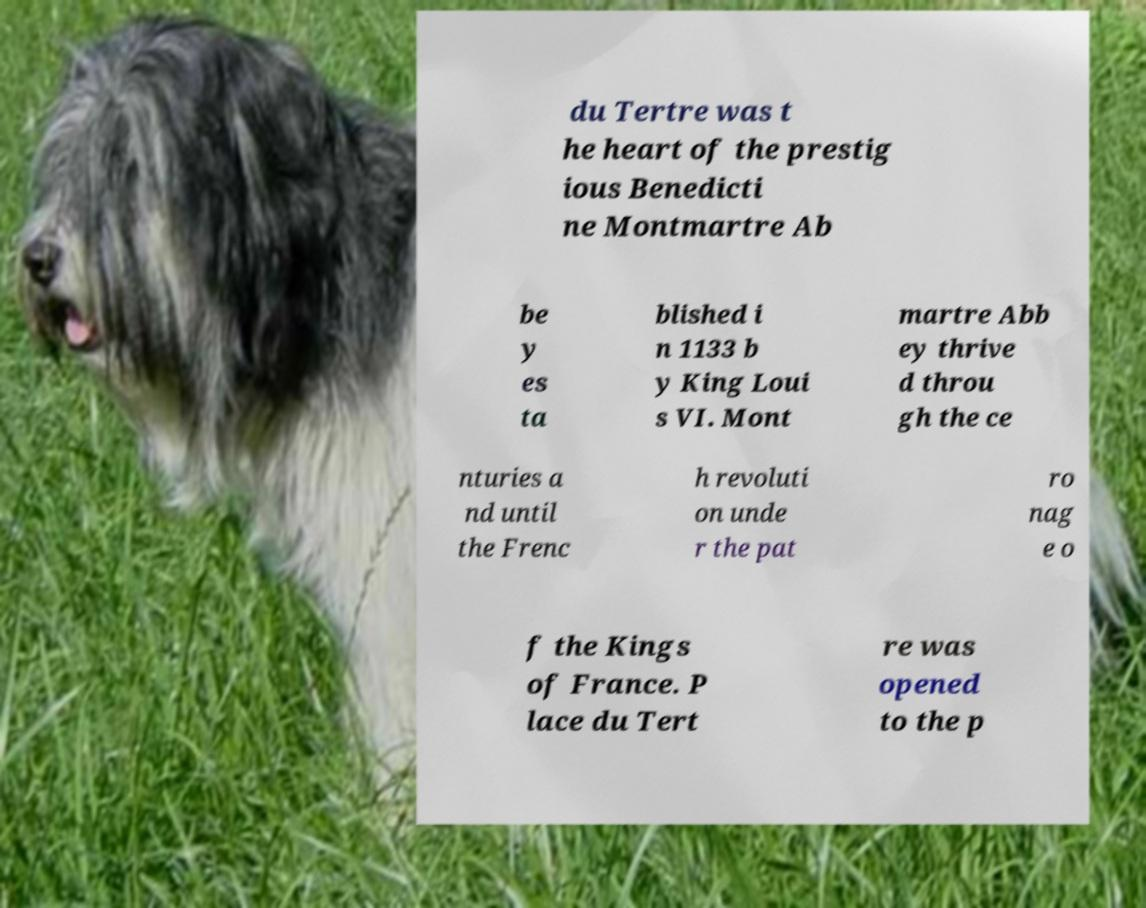Could you extract and type out the text from this image? du Tertre was t he heart of the prestig ious Benedicti ne Montmartre Ab be y es ta blished i n 1133 b y King Loui s VI. Mont martre Abb ey thrive d throu gh the ce nturies a nd until the Frenc h revoluti on unde r the pat ro nag e o f the Kings of France. P lace du Tert re was opened to the p 